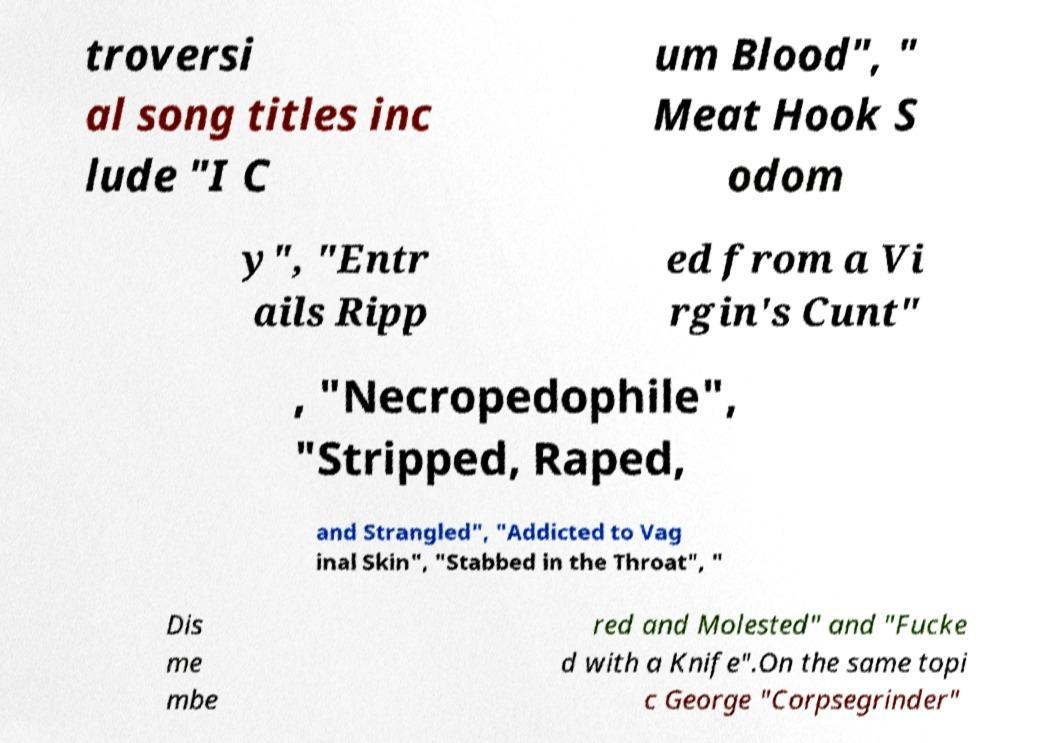Please read and relay the text visible in this image. What does it say? troversi al song titles inc lude "I C um Blood", " Meat Hook S odom y", "Entr ails Ripp ed from a Vi rgin's Cunt" , "Necropedophile", "Stripped, Raped, and Strangled", "Addicted to Vag inal Skin", "Stabbed in the Throat", " Dis me mbe red and Molested" and "Fucke d with a Knife".On the same topi c George "Corpsegrinder" 